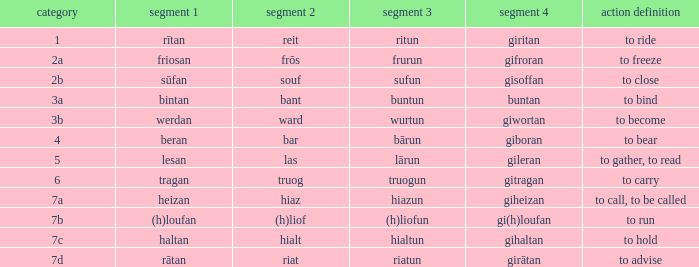What is the part 4 when part 1 is "lesan"? Gileran. 